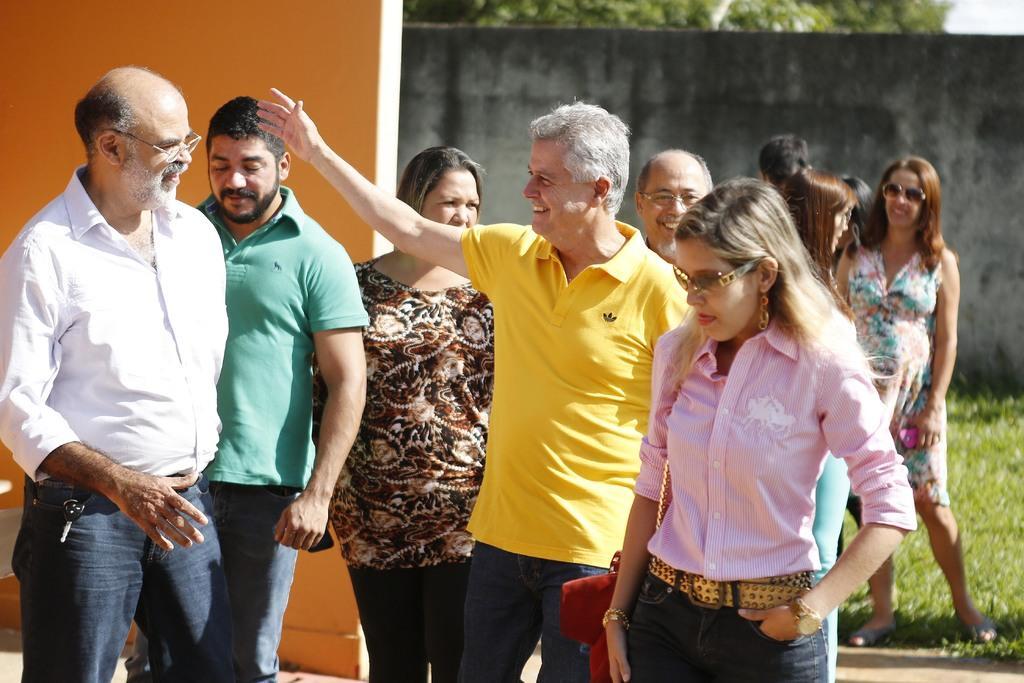Can you describe this image briefly? Here we can see few people standing. In the background we can see walls,grass,trees and sky. 